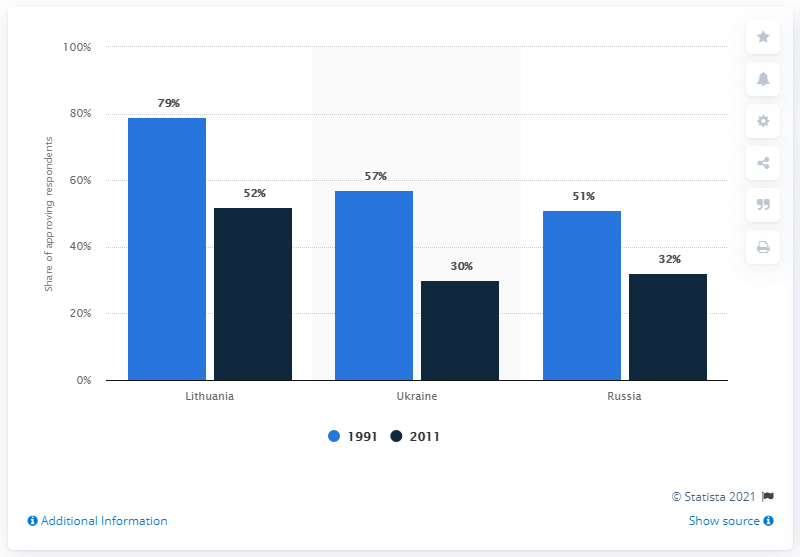Indicate a few pertinent items in this graphic. According to a survey conducted in 1991, 32% of Russians believed that they should rely on a democratic form of government. 